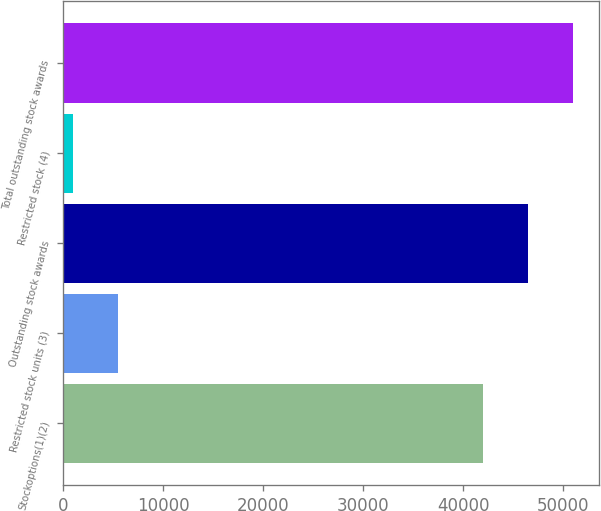Convert chart. <chart><loc_0><loc_0><loc_500><loc_500><bar_chart><fcel>Stockoptions(1)(2)<fcel>Restricted stock units (3)<fcel>Outstanding stock awards<fcel>Restricted stock (4)<fcel>Total outstanding stock awards<nl><fcel>42005<fcel>5505<fcel>46499<fcel>1011<fcel>50993<nl></chart> 